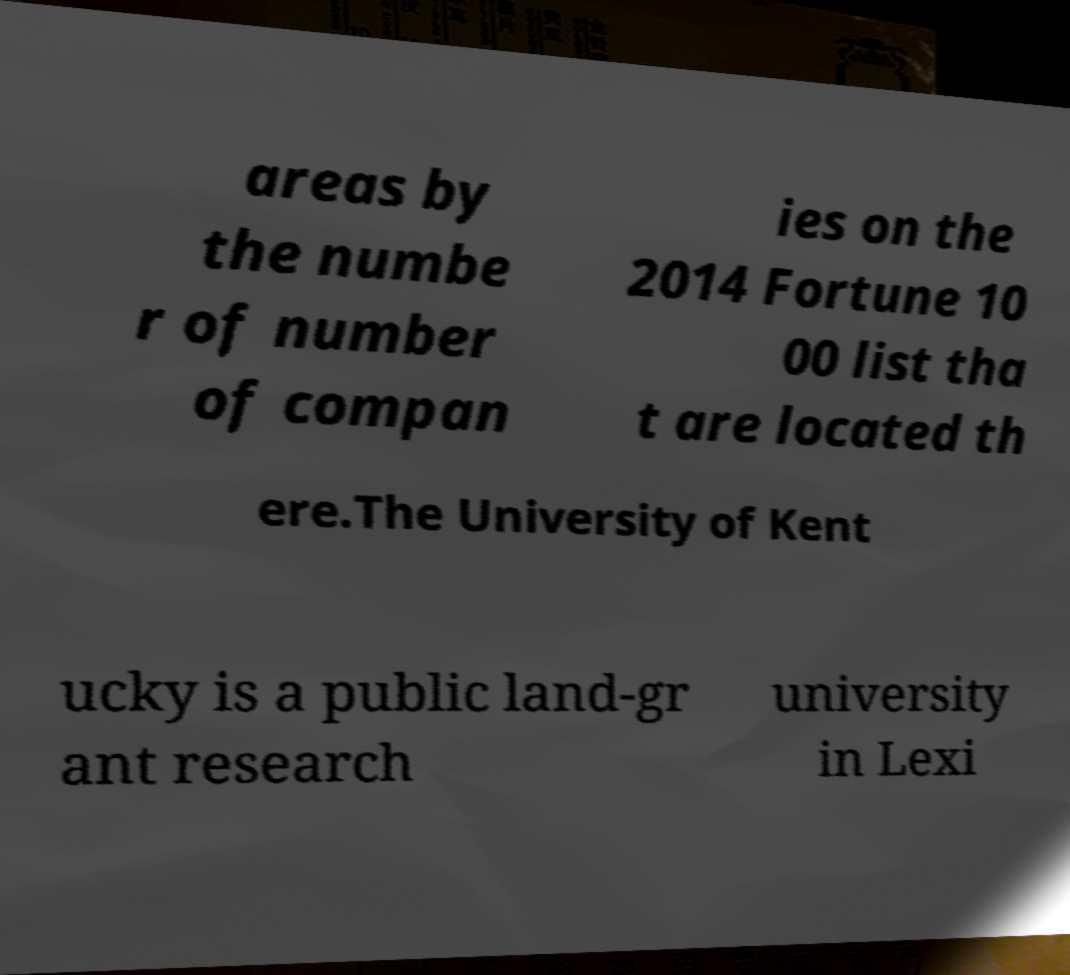Could you extract and type out the text from this image? areas by the numbe r of number of compan ies on the 2014 Fortune 10 00 list tha t are located th ere.The University of Kent ucky is a public land-gr ant research university in Lexi 